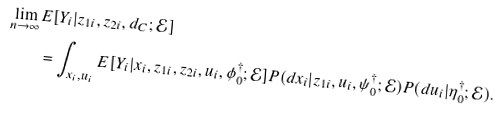<formula> <loc_0><loc_0><loc_500><loc_500>\lim _ { n \rightarrow \infty } & E [ Y _ { i } | z _ { 1 i } , z _ { 2 i } , d _ { C } ; \mathcal { E } ] \\ & = \int _ { x _ { i } , u _ { i } } E [ Y _ { i } | x _ { i } , z _ { 1 i } , z _ { 2 i } , u _ { i } , \phi _ { 0 } ^ { \dagger } ; \mathcal { E } ] P ( d x _ { i } | z _ { 1 i } , u _ { i } , \psi _ { 0 } ^ { \dagger } ; \mathcal { E } ) P ( d u _ { i } | \eta _ { 0 } ^ { \dagger } ; \mathcal { E } ) .</formula> 